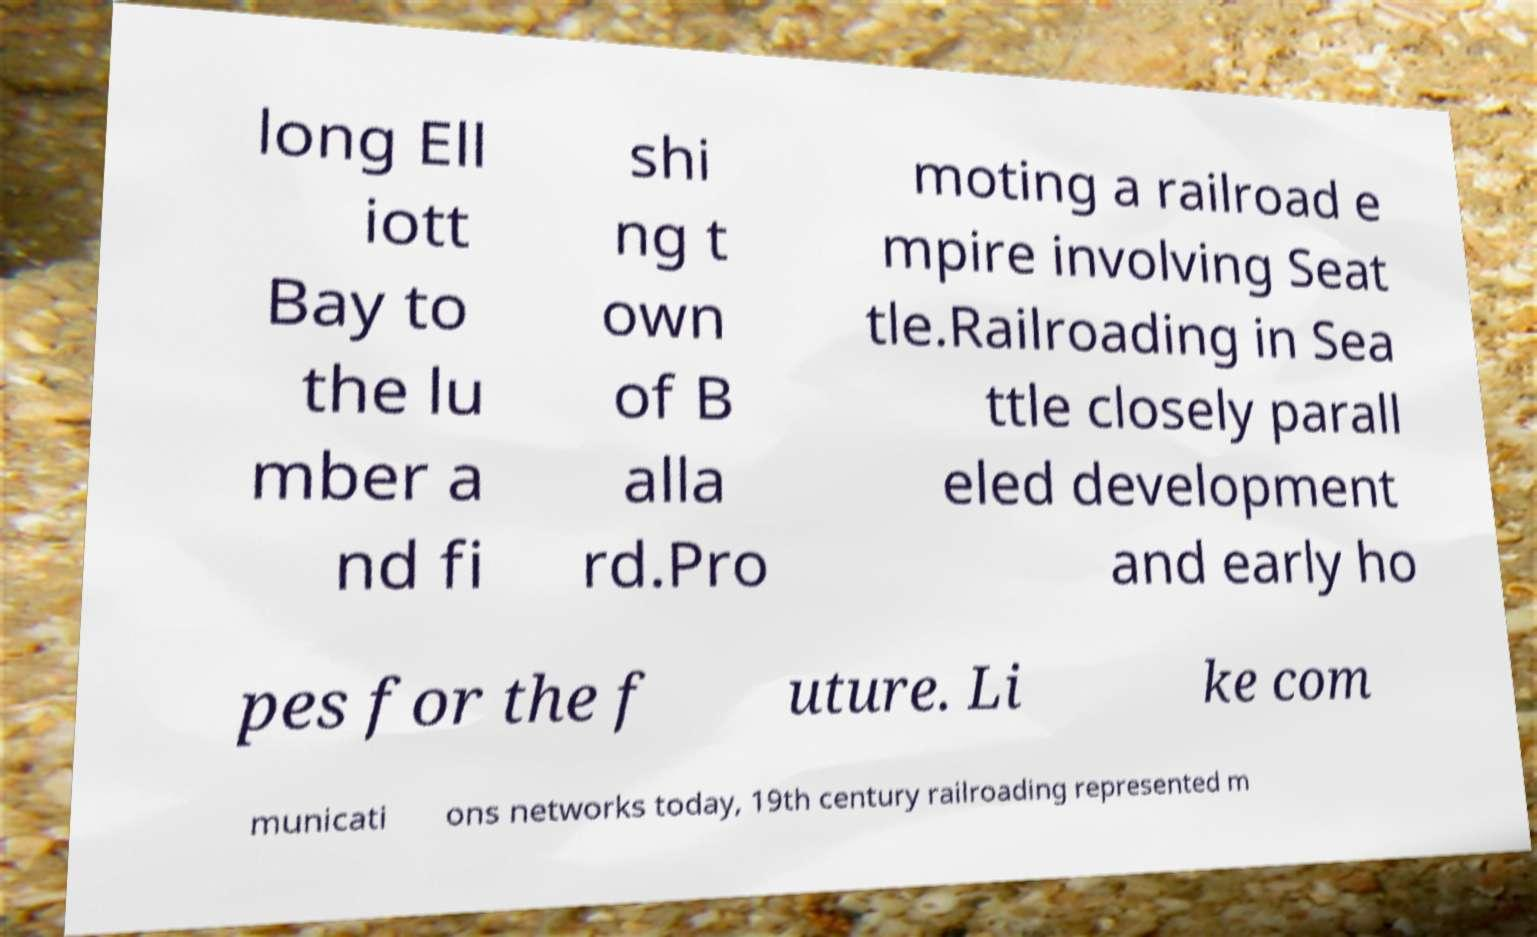Can you accurately transcribe the text from the provided image for me? long Ell iott Bay to the lu mber a nd fi shi ng t own of B alla rd.Pro moting a railroad e mpire involving Seat tle.Railroading in Sea ttle closely parall eled development and early ho pes for the f uture. Li ke com municati ons networks today, 19th century railroading represented m 